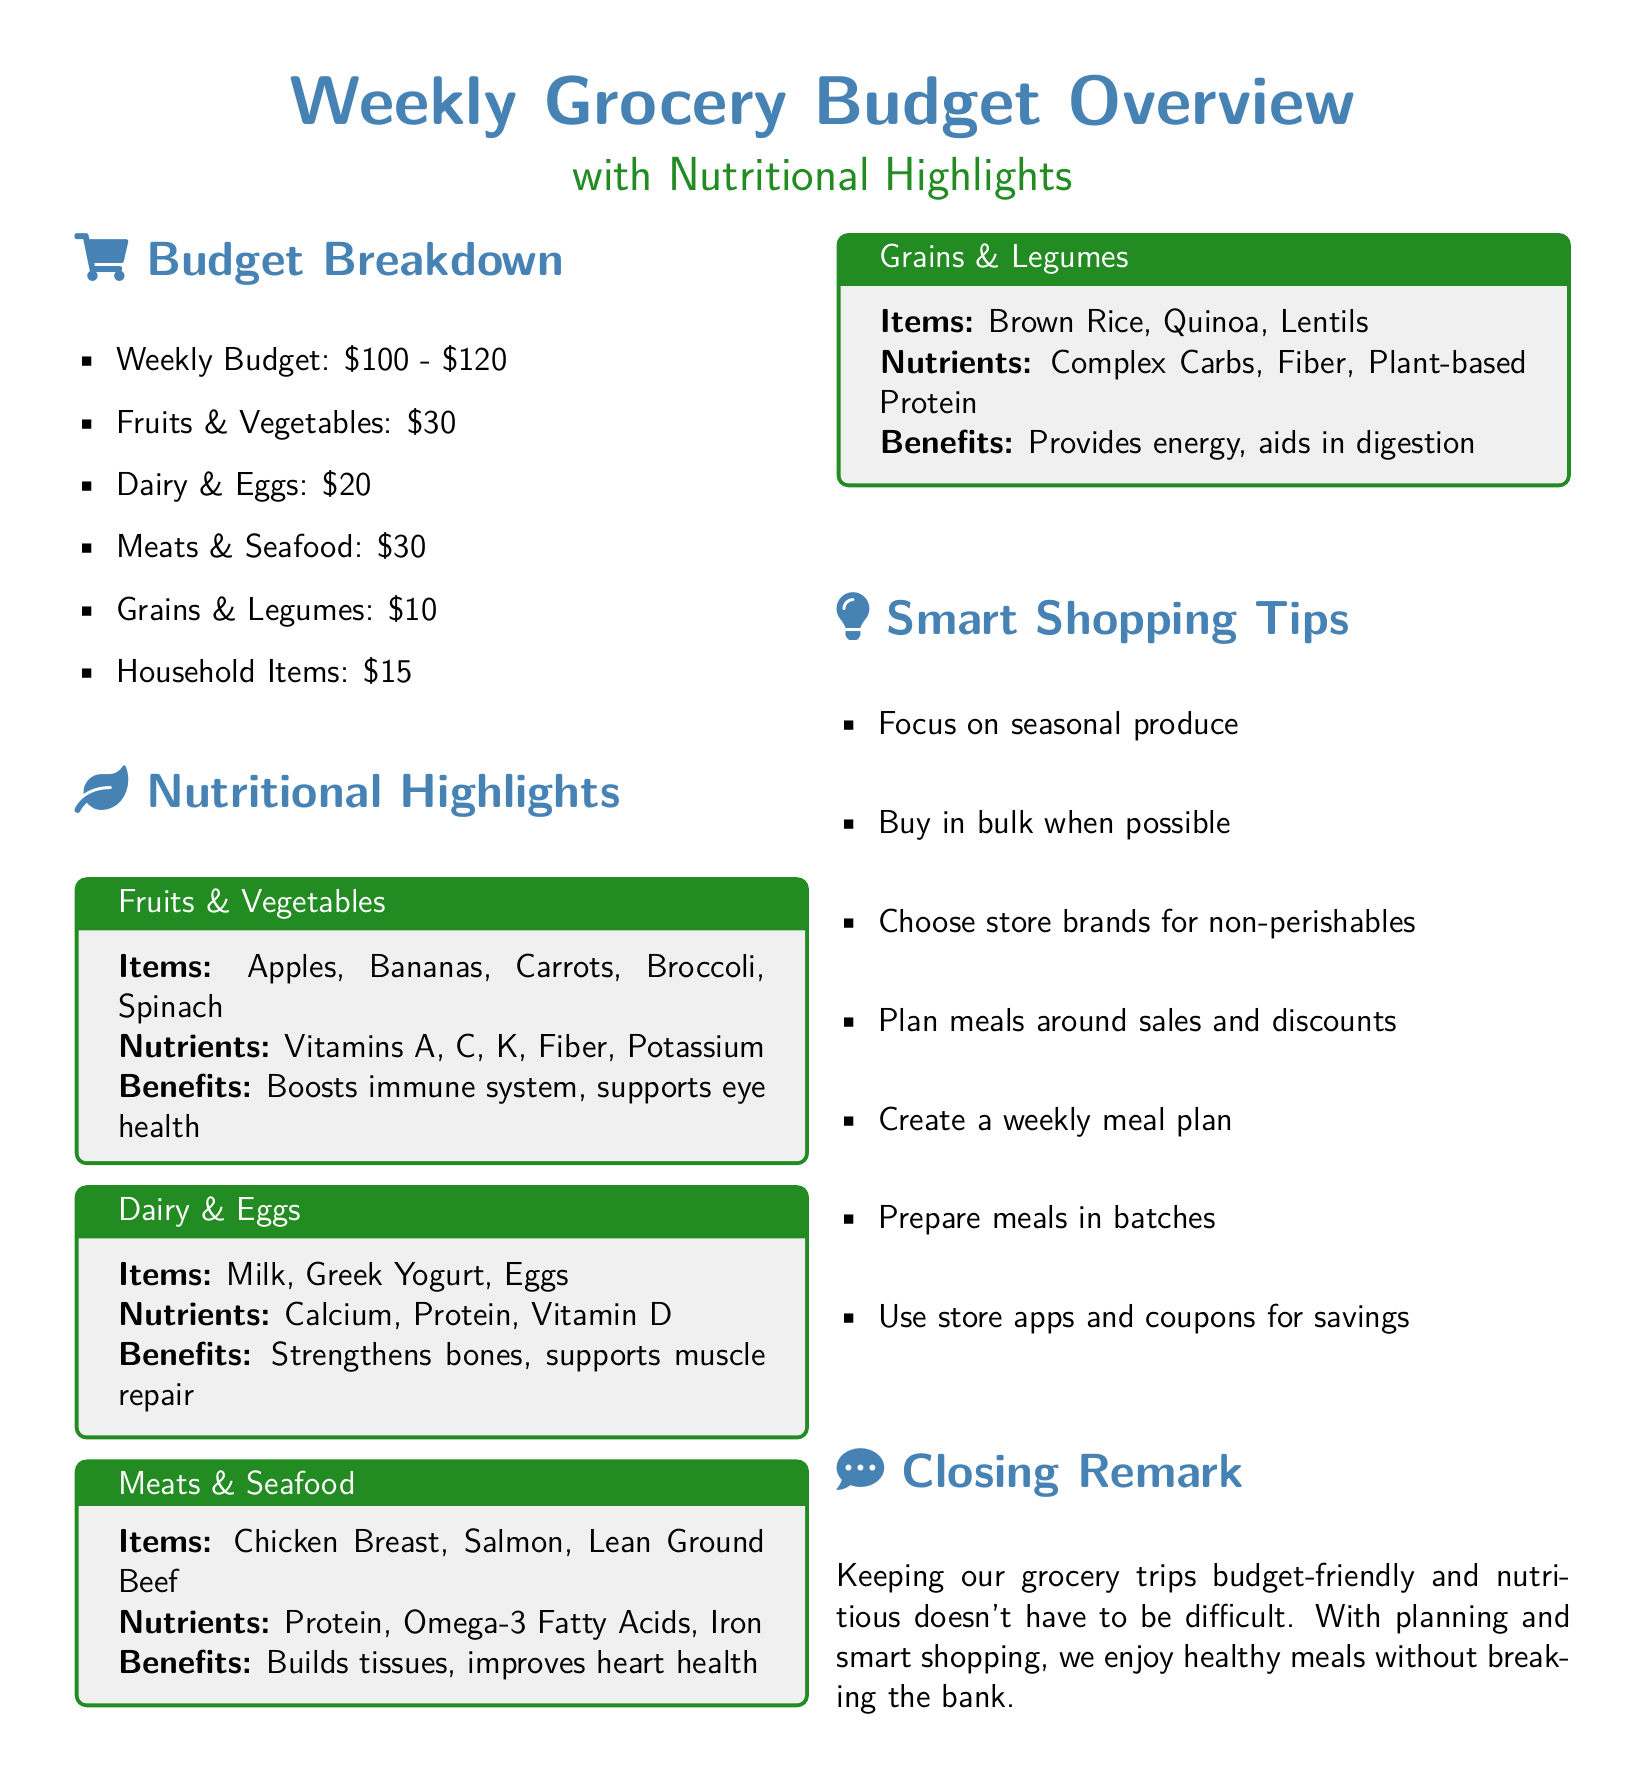What is the weekly budget range? The weekly budget range is mentioned as between $100 and $120.
Answer: $100 - $120 How much is allocated for fruits and vegetables? The budget breakdown indicates that $30 is allocated for fruits and vegetables.
Answer: $30 What nutrients are present in dairy and eggs? The section on dairy and eggs lists calcium, protein, and vitamin D as the nutrients present.
Answer: Calcium, Protein, Vitamin D Which item is included in the meats and seafood category? The meats and seafood section provides specific items, among which chicken breast is listed.
Answer: Chicken Breast What is one benefit of consuming grains and legumes? The document states that one benefit of grains and legumes is to provide energy.
Answer: Provides energy What is the total budget for household items? The budget breakdown specifies that the total budget for household items is $15.
Answer: $15 Which shopping tip advises on meal planning? The smart shopping tips recommend creating a weekly meal plan as one of the strategies.
Answer: Create a weekly meal plan What type of food items should be focused on according to the smart shopping tips? The document mentions focusing on seasonal produce as a recommended shopping strategy.
Answer: Seasonal produce What is one key benefit of fruits and vegetables? The document highlights that one benefit of fruits and vegetables is boosting the immune system.
Answer: Boosts immune system 